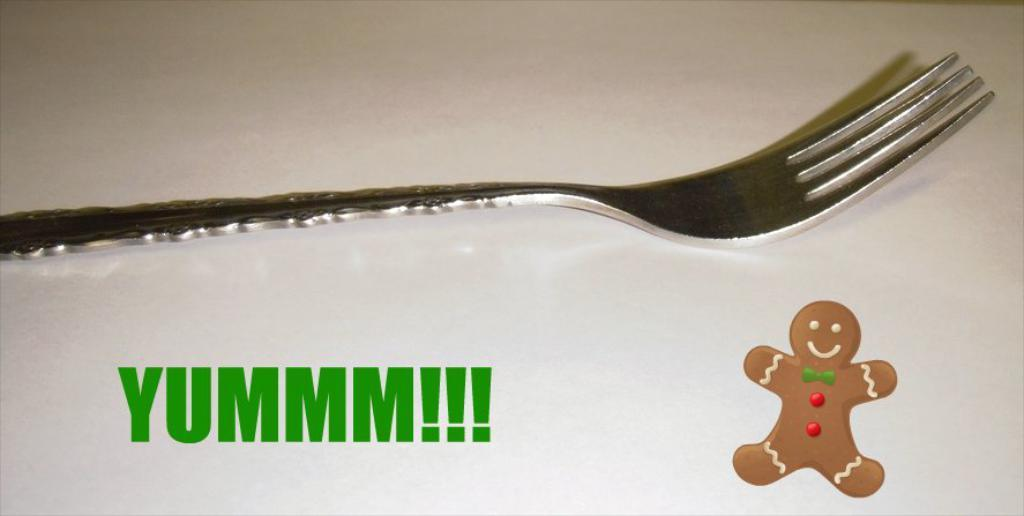What object is placed on a white platform in the image? There is a fork on a white platform in the image. What else can be seen in the image besides the fork? There is text and a toy in the image. What type of silk fabric is draped over the toy in the image? There is no silk fabric present in the image; it only features a fork on a white platform, text, and a toy. 